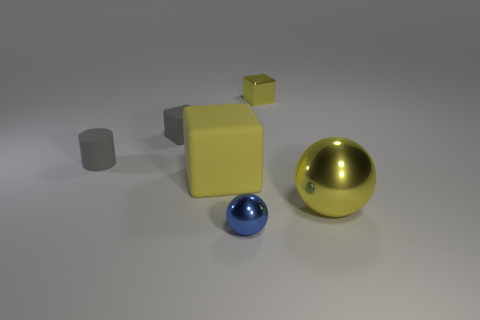Is the number of blocks that are behind the large matte block the same as the number of big yellow matte objects that are behind the cylinder?
Provide a succinct answer. No. Does the ball on the left side of the large metal object have the same material as the tiny cylinder?
Make the answer very short. No. There is a metallic object that is both behind the small metallic ball and in front of the tiny gray rubber block; what is its color?
Ensure brevity in your answer.  Yellow. What number of big spheres are right of the small gray rubber object that is in front of the small gray rubber cube?
Provide a succinct answer. 1. There is a yellow thing that is the same shape as the small blue object; what is its material?
Offer a very short reply. Metal. What color is the small sphere?
Your response must be concise. Blue. How many things are metal cubes or gray balls?
Keep it short and to the point. 1. What is the shape of the gray matte object to the left of the matte block that is behind the big rubber block?
Provide a short and direct response. Cylinder. How many other objects are there of the same material as the small gray cylinder?
Provide a succinct answer. 2. Is the material of the gray cylinder the same as the yellow thing that is behind the small matte cylinder?
Ensure brevity in your answer.  No. 